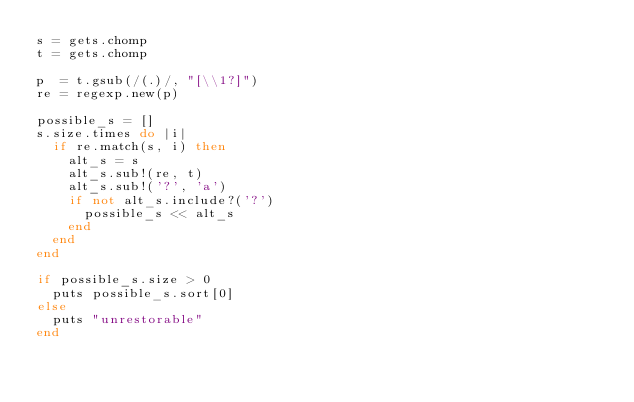Convert code to text. <code><loc_0><loc_0><loc_500><loc_500><_Ruby_>s = gets.chomp
t = gets.chomp

p  = t.gsub(/(.)/, "[\\1?]")
re = regexp.new(p)

possible_s = []
s.size.times do |i|
  if re.match(s, i) then
    alt_s = s
    alt_s.sub!(re, t)
    alt_s.sub!('?', 'a')
    if not alt_s.include?('?')
      possible_s << alt_s
    end
  end
end

if possible_s.size > 0
  puts possible_s.sort[0]
else
  puts "unrestorable"
end
</code> 